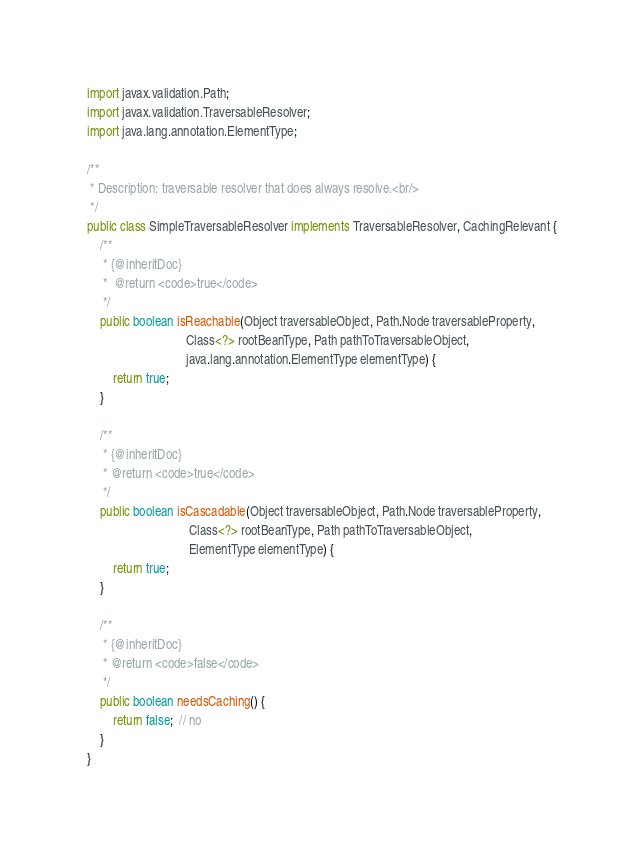<code> <loc_0><loc_0><loc_500><loc_500><_Java_>
import javax.validation.Path;
import javax.validation.TraversableResolver;
import java.lang.annotation.ElementType;

/**
 * Description: traversable resolver that does always resolve.<br/>
 */
public class SimpleTraversableResolver implements TraversableResolver, CachingRelevant {
    /**
     * {@inheritDoc}
     *  @return <code>true</code>
     */
    public boolean isReachable(Object traversableObject, Path.Node traversableProperty,
                               Class<?> rootBeanType, Path pathToTraversableObject,
                               java.lang.annotation.ElementType elementType) {
        return true;
    }

    /**
     * {@inheritDoc}
     * @return <code>true</code>
     */
    public boolean isCascadable(Object traversableObject, Path.Node traversableProperty,
                                Class<?> rootBeanType, Path pathToTraversableObject,
                                ElementType elementType) {
        return true;
    }

    /**
     * {@inheritDoc}
     * @return <code>false</code>
     */
    public boolean needsCaching() {
        return false;  // no
    }
}
</code> 